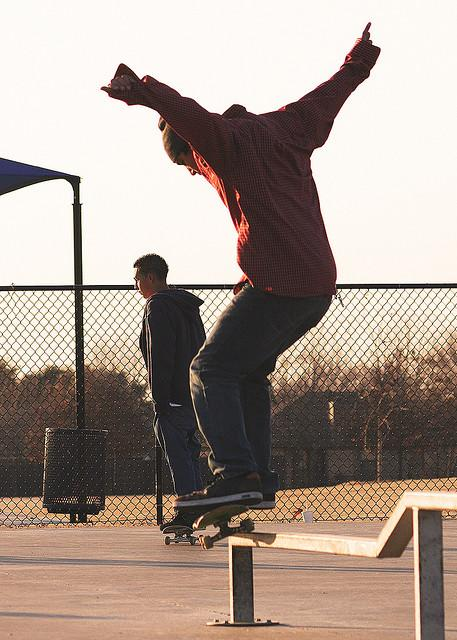What is the skater doing on the rail? Please explain your reasoning. grinding. The skater is grinding on top of the rail. 